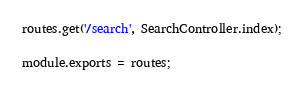Convert code to text. <code><loc_0><loc_0><loc_500><loc_500><_JavaScript_>routes.get('/search', SearchController.index);

module.exports = routes;</code> 